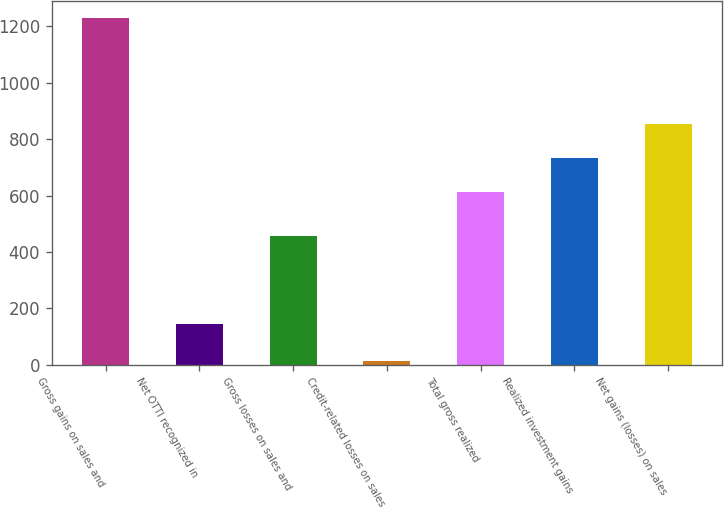<chart> <loc_0><loc_0><loc_500><loc_500><bar_chart><fcel>Gross gains on sales and<fcel>Net OTTI recognized in<fcel>Gross losses on sales and<fcel>Credit-related losses on sales<fcel>Total gross realized<fcel>Realized investment gains<fcel>Net gains (losses) on sales<nl><fcel>1229<fcel>144<fcel>456<fcel>12<fcel>612<fcel>733.7<fcel>855.4<nl></chart> 